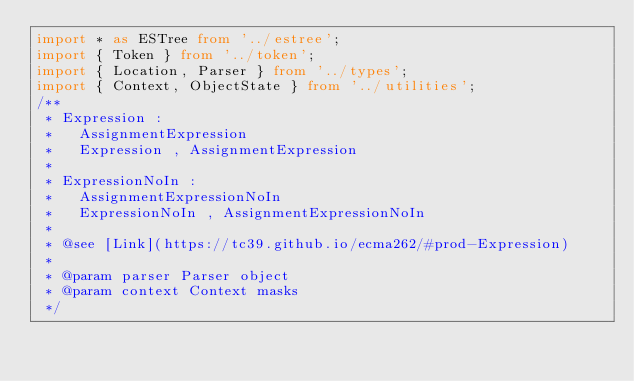Convert code to text. <code><loc_0><loc_0><loc_500><loc_500><_TypeScript_>import * as ESTree from '../estree';
import { Token } from '../token';
import { Location, Parser } from '../types';
import { Context, ObjectState } from '../utilities';
/**
 * Expression :
 *   AssignmentExpression
 *   Expression , AssignmentExpression
 *
 * ExpressionNoIn :
 *   AssignmentExpressionNoIn
 *   ExpressionNoIn , AssignmentExpressionNoIn
 *
 * @see [Link](https://tc39.github.io/ecma262/#prod-Expression)
 *
 * @param parser Parser object
 * @param context Context masks
 */</code> 